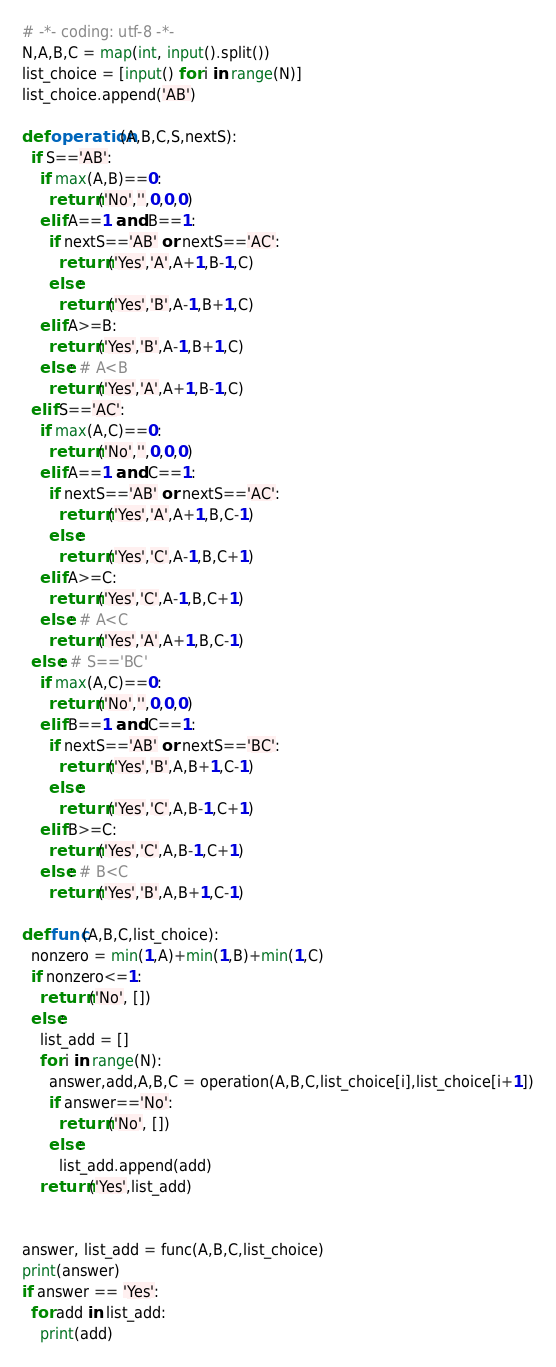<code> <loc_0><loc_0><loc_500><loc_500><_Python_># -*- coding: utf-8 -*-
N,A,B,C = map(int, input().split())
list_choice = [input() for i in range(N)]
list_choice.append('AB')

def operation(A,B,C,S,nextS):
  if S=='AB':
    if max(A,B)==0:
      return ('No','',0,0,0)
    elif A==1 and B==1:
      if nextS=='AB' or nextS=='AC':
        return ('Yes','A',A+1,B-1,C)
      else:
        return ('Yes','B',A-1,B+1,C)  
    elif A>=B:
      return ('Yes','B',A-1,B+1,C)
    else: # A<B
      return ('Yes','A',A+1,B-1,C)
  elif S=='AC':
    if max(A,C)==0:
      return ('No','',0,0,0)
    elif A==1 and C==1:
      if nextS=='AB' or nextS=='AC':
        return ('Yes','A',A+1,B,C-1)
      else:
        return ('Yes','C',A-1,B,C+1)  
    elif A>=C:
      return ('Yes','C',A-1,B,C+1)
    else: # A<C
      return ('Yes','A',A+1,B,C-1)
  else: # S=='BC'
    if max(A,C)==0:
      return ('No','',0,0,0)
    elif B==1 and C==1:
      if nextS=='AB' or nextS=='BC':
        return ('Yes','B',A,B+1,C-1)
      else:
        return ('Yes','C',A,B-1,C+1)  
    elif B>=C:
      return ('Yes','C',A,B-1,C+1)
    else: # B<C
      return ('Yes','B',A,B+1,C-1)
  
def func(A,B,C,list_choice):
  nonzero = min(1,A)+min(1,B)+min(1,C)
  if nonzero<=1:
    return ('No', [])
  else:
    list_add = []
    for i in range(N):
      answer,add,A,B,C = operation(A,B,C,list_choice[i],list_choice[i+1])
      if answer=='No':
        return ('No', [])
      else:
        list_add.append(add)
    return ('Yes',list_add)
    
  
answer, list_add = func(A,B,C,list_choice)
print(answer)
if answer == 'Yes':
  for add in list_add:
    print(add)</code> 